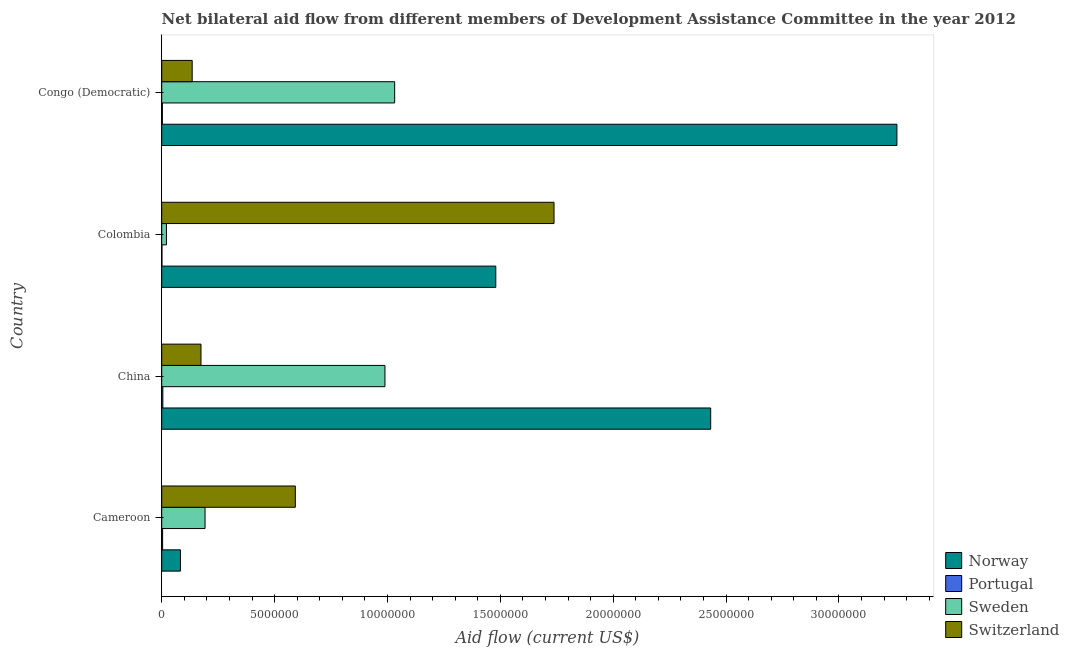How many groups of bars are there?
Provide a succinct answer. 4. Are the number of bars per tick equal to the number of legend labels?
Your response must be concise. Yes. What is the label of the 1st group of bars from the top?
Offer a very short reply. Congo (Democratic). In how many cases, is the number of bars for a given country not equal to the number of legend labels?
Keep it short and to the point. 0. What is the amount of aid given by switzerland in Colombia?
Offer a terse response. 1.74e+07. Across all countries, what is the maximum amount of aid given by portugal?
Offer a very short reply. 5.00e+04. Across all countries, what is the minimum amount of aid given by norway?
Offer a very short reply. 8.30e+05. In which country was the amount of aid given by sweden maximum?
Your response must be concise. Congo (Democratic). What is the total amount of aid given by switzerland in the graph?
Offer a very short reply. 2.64e+07. What is the difference between the amount of aid given by norway in Cameroon and that in Colombia?
Give a very brief answer. -1.40e+07. What is the difference between the amount of aid given by norway in China and the amount of aid given by switzerland in Colombia?
Provide a succinct answer. 6.94e+06. What is the average amount of aid given by norway per country?
Ensure brevity in your answer.  1.81e+07. What is the difference between the amount of aid given by portugal and amount of aid given by sweden in Colombia?
Your response must be concise. -2.00e+05. Is the amount of aid given by norway in Cameroon less than that in Colombia?
Your answer should be compact. Yes. What is the difference between the highest and the second highest amount of aid given by norway?
Offer a terse response. 8.25e+06. What is the difference between the highest and the lowest amount of aid given by norway?
Provide a succinct answer. 3.17e+07. In how many countries, is the amount of aid given by norway greater than the average amount of aid given by norway taken over all countries?
Your answer should be very brief. 2. What does the 2nd bar from the top in Colombia represents?
Keep it short and to the point. Sweden. Are the values on the major ticks of X-axis written in scientific E-notation?
Your response must be concise. No. Does the graph contain grids?
Your answer should be compact. No. How many legend labels are there?
Keep it short and to the point. 4. How are the legend labels stacked?
Your answer should be compact. Vertical. What is the title of the graph?
Give a very brief answer. Net bilateral aid flow from different members of Development Assistance Committee in the year 2012. What is the label or title of the Y-axis?
Provide a short and direct response. Country. What is the Aid flow (current US$) in Norway in Cameroon?
Provide a succinct answer. 8.30e+05. What is the Aid flow (current US$) in Portugal in Cameroon?
Provide a short and direct response. 4.00e+04. What is the Aid flow (current US$) of Sweden in Cameroon?
Give a very brief answer. 1.92e+06. What is the Aid flow (current US$) of Switzerland in Cameroon?
Ensure brevity in your answer.  5.92e+06. What is the Aid flow (current US$) of Norway in China?
Offer a very short reply. 2.43e+07. What is the Aid flow (current US$) in Portugal in China?
Make the answer very short. 5.00e+04. What is the Aid flow (current US$) of Sweden in China?
Provide a succinct answer. 9.89e+06. What is the Aid flow (current US$) of Switzerland in China?
Provide a succinct answer. 1.74e+06. What is the Aid flow (current US$) of Norway in Colombia?
Your response must be concise. 1.48e+07. What is the Aid flow (current US$) in Sweden in Colombia?
Your response must be concise. 2.10e+05. What is the Aid flow (current US$) in Switzerland in Colombia?
Your answer should be very brief. 1.74e+07. What is the Aid flow (current US$) in Norway in Congo (Democratic)?
Your answer should be compact. 3.26e+07. What is the Aid flow (current US$) of Sweden in Congo (Democratic)?
Provide a short and direct response. 1.03e+07. What is the Aid flow (current US$) in Switzerland in Congo (Democratic)?
Offer a terse response. 1.35e+06. Across all countries, what is the maximum Aid flow (current US$) of Norway?
Provide a succinct answer. 3.26e+07. Across all countries, what is the maximum Aid flow (current US$) of Sweden?
Offer a very short reply. 1.03e+07. Across all countries, what is the maximum Aid flow (current US$) in Switzerland?
Keep it short and to the point. 1.74e+07. Across all countries, what is the minimum Aid flow (current US$) in Norway?
Keep it short and to the point. 8.30e+05. Across all countries, what is the minimum Aid flow (current US$) in Portugal?
Ensure brevity in your answer.  10000. Across all countries, what is the minimum Aid flow (current US$) in Sweden?
Provide a short and direct response. 2.10e+05. Across all countries, what is the minimum Aid flow (current US$) of Switzerland?
Your answer should be very brief. 1.35e+06. What is the total Aid flow (current US$) of Norway in the graph?
Offer a very short reply. 7.25e+07. What is the total Aid flow (current US$) in Sweden in the graph?
Provide a succinct answer. 2.23e+07. What is the total Aid flow (current US$) in Switzerland in the graph?
Your response must be concise. 2.64e+07. What is the difference between the Aid flow (current US$) in Norway in Cameroon and that in China?
Provide a succinct answer. -2.35e+07. What is the difference between the Aid flow (current US$) in Portugal in Cameroon and that in China?
Your response must be concise. -10000. What is the difference between the Aid flow (current US$) of Sweden in Cameroon and that in China?
Offer a terse response. -7.97e+06. What is the difference between the Aid flow (current US$) in Switzerland in Cameroon and that in China?
Offer a terse response. 4.18e+06. What is the difference between the Aid flow (current US$) of Norway in Cameroon and that in Colombia?
Your response must be concise. -1.40e+07. What is the difference between the Aid flow (current US$) of Portugal in Cameroon and that in Colombia?
Ensure brevity in your answer.  3.00e+04. What is the difference between the Aid flow (current US$) in Sweden in Cameroon and that in Colombia?
Offer a terse response. 1.71e+06. What is the difference between the Aid flow (current US$) in Switzerland in Cameroon and that in Colombia?
Give a very brief answer. -1.15e+07. What is the difference between the Aid flow (current US$) of Norway in Cameroon and that in Congo (Democratic)?
Ensure brevity in your answer.  -3.17e+07. What is the difference between the Aid flow (current US$) of Portugal in Cameroon and that in Congo (Democratic)?
Your answer should be compact. 10000. What is the difference between the Aid flow (current US$) in Sweden in Cameroon and that in Congo (Democratic)?
Offer a terse response. -8.40e+06. What is the difference between the Aid flow (current US$) of Switzerland in Cameroon and that in Congo (Democratic)?
Give a very brief answer. 4.57e+06. What is the difference between the Aid flow (current US$) in Norway in China and that in Colombia?
Make the answer very short. 9.52e+06. What is the difference between the Aid flow (current US$) in Portugal in China and that in Colombia?
Keep it short and to the point. 4.00e+04. What is the difference between the Aid flow (current US$) in Sweden in China and that in Colombia?
Provide a succinct answer. 9.68e+06. What is the difference between the Aid flow (current US$) in Switzerland in China and that in Colombia?
Your answer should be very brief. -1.56e+07. What is the difference between the Aid flow (current US$) of Norway in China and that in Congo (Democratic)?
Your answer should be compact. -8.25e+06. What is the difference between the Aid flow (current US$) in Sweden in China and that in Congo (Democratic)?
Provide a short and direct response. -4.30e+05. What is the difference between the Aid flow (current US$) in Norway in Colombia and that in Congo (Democratic)?
Provide a short and direct response. -1.78e+07. What is the difference between the Aid flow (current US$) of Sweden in Colombia and that in Congo (Democratic)?
Offer a very short reply. -1.01e+07. What is the difference between the Aid flow (current US$) of Switzerland in Colombia and that in Congo (Democratic)?
Give a very brief answer. 1.60e+07. What is the difference between the Aid flow (current US$) of Norway in Cameroon and the Aid flow (current US$) of Portugal in China?
Offer a terse response. 7.80e+05. What is the difference between the Aid flow (current US$) in Norway in Cameroon and the Aid flow (current US$) in Sweden in China?
Your response must be concise. -9.06e+06. What is the difference between the Aid flow (current US$) of Norway in Cameroon and the Aid flow (current US$) of Switzerland in China?
Provide a short and direct response. -9.10e+05. What is the difference between the Aid flow (current US$) in Portugal in Cameroon and the Aid flow (current US$) in Sweden in China?
Offer a very short reply. -9.85e+06. What is the difference between the Aid flow (current US$) in Portugal in Cameroon and the Aid flow (current US$) in Switzerland in China?
Your answer should be very brief. -1.70e+06. What is the difference between the Aid flow (current US$) of Norway in Cameroon and the Aid flow (current US$) of Portugal in Colombia?
Ensure brevity in your answer.  8.20e+05. What is the difference between the Aid flow (current US$) in Norway in Cameroon and the Aid flow (current US$) in Sweden in Colombia?
Provide a short and direct response. 6.20e+05. What is the difference between the Aid flow (current US$) in Norway in Cameroon and the Aid flow (current US$) in Switzerland in Colombia?
Offer a terse response. -1.66e+07. What is the difference between the Aid flow (current US$) of Portugal in Cameroon and the Aid flow (current US$) of Switzerland in Colombia?
Provide a short and direct response. -1.73e+07. What is the difference between the Aid flow (current US$) of Sweden in Cameroon and the Aid flow (current US$) of Switzerland in Colombia?
Your answer should be very brief. -1.55e+07. What is the difference between the Aid flow (current US$) in Norway in Cameroon and the Aid flow (current US$) in Sweden in Congo (Democratic)?
Offer a terse response. -9.49e+06. What is the difference between the Aid flow (current US$) in Norway in Cameroon and the Aid flow (current US$) in Switzerland in Congo (Democratic)?
Ensure brevity in your answer.  -5.20e+05. What is the difference between the Aid flow (current US$) of Portugal in Cameroon and the Aid flow (current US$) of Sweden in Congo (Democratic)?
Offer a terse response. -1.03e+07. What is the difference between the Aid flow (current US$) of Portugal in Cameroon and the Aid flow (current US$) of Switzerland in Congo (Democratic)?
Provide a succinct answer. -1.31e+06. What is the difference between the Aid flow (current US$) in Sweden in Cameroon and the Aid flow (current US$) in Switzerland in Congo (Democratic)?
Offer a very short reply. 5.70e+05. What is the difference between the Aid flow (current US$) in Norway in China and the Aid flow (current US$) in Portugal in Colombia?
Your answer should be very brief. 2.43e+07. What is the difference between the Aid flow (current US$) of Norway in China and the Aid flow (current US$) of Sweden in Colombia?
Make the answer very short. 2.41e+07. What is the difference between the Aid flow (current US$) in Norway in China and the Aid flow (current US$) in Switzerland in Colombia?
Make the answer very short. 6.94e+06. What is the difference between the Aid flow (current US$) in Portugal in China and the Aid flow (current US$) in Sweden in Colombia?
Your response must be concise. -1.60e+05. What is the difference between the Aid flow (current US$) of Portugal in China and the Aid flow (current US$) of Switzerland in Colombia?
Offer a terse response. -1.73e+07. What is the difference between the Aid flow (current US$) of Sweden in China and the Aid flow (current US$) of Switzerland in Colombia?
Offer a terse response. -7.49e+06. What is the difference between the Aid flow (current US$) of Norway in China and the Aid flow (current US$) of Portugal in Congo (Democratic)?
Your answer should be very brief. 2.43e+07. What is the difference between the Aid flow (current US$) in Norway in China and the Aid flow (current US$) in Sweden in Congo (Democratic)?
Ensure brevity in your answer.  1.40e+07. What is the difference between the Aid flow (current US$) in Norway in China and the Aid flow (current US$) in Switzerland in Congo (Democratic)?
Your answer should be very brief. 2.30e+07. What is the difference between the Aid flow (current US$) of Portugal in China and the Aid flow (current US$) of Sweden in Congo (Democratic)?
Your answer should be very brief. -1.03e+07. What is the difference between the Aid flow (current US$) of Portugal in China and the Aid flow (current US$) of Switzerland in Congo (Democratic)?
Your answer should be compact. -1.30e+06. What is the difference between the Aid flow (current US$) in Sweden in China and the Aid flow (current US$) in Switzerland in Congo (Democratic)?
Your answer should be very brief. 8.54e+06. What is the difference between the Aid flow (current US$) of Norway in Colombia and the Aid flow (current US$) of Portugal in Congo (Democratic)?
Your answer should be very brief. 1.48e+07. What is the difference between the Aid flow (current US$) of Norway in Colombia and the Aid flow (current US$) of Sweden in Congo (Democratic)?
Your response must be concise. 4.48e+06. What is the difference between the Aid flow (current US$) in Norway in Colombia and the Aid flow (current US$) in Switzerland in Congo (Democratic)?
Your answer should be very brief. 1.34e+07. What is the difference between the Aid flow (current US$) of Portugal in Colombia and the Aid flow (current US$) of Sweden in Congo (Democratic)?
Give a very brief answer. -1.03e+07. What is the difference between the Aid flow (current US$) of Portugal in Colombia and the Aid flow (current US$) of Switzerland in Congo (Democratic)?
Your response must be concise. -1.34e+06. What is the difference between the Aid flow (current US$) of Sweden in Colombia and the Aid flow (current US$) of Switzerland in Congo (Democratic)?
Make the answer very short. -1.14e+06. What is the average Aid flow (current US$) in Norway per country?
Make the answer very short. 1.81e+07. What is the average Aid flow (current US$) of Portugal per country?
Provide a short and direct response. 3.25e+04. What is the average Aid flow (current US$) in Sweden per country?
Your response must be concise. 5.58e+06. What is the average Aid flow (current US$) in Switzerland per country?
Ensure brevity in your answer.  6.60e+06. What is the difference between the Aid flow (current US$) of Norway and Aid flow (current US$) of Portugal in Cameroon?
Your response must be concise. 7.90e+05. What is the difference between the Aid flow (current US$) of Norway and Aid flow (current US$) of Sweden in Cameroon?
Provide a short and direct response. -1.09e+06. What is the difference between the Aid flow (current US$) in Norway and Aid flow (current US$) in Switzerland in Cameroon?
Provide a short and direct response. -5.09e+06. What is the difference between the Aid flow (current US$) in Portugal and Aid flow (current US$) in Sweden in Cameroon?
Your response must be concise. -1.88e+06. What is the difference between the Aid flow (current US$) of Portugal and Aid flow (current US$) of Switzerland in Cameroon?
Keep it short and to the point. -5.88e+06. What is the difference between the Aid flow (current US$) of Sweden and Aid flow (current US$) of Switzerland in Cameroon?
Your answer should be very brief. -4.00e+06. What is the difference between the Aid flow (current US$) in Norway and Aid flow (current US$) in Portugal in China?
Offer a very short reply. 2.43e+07. What is the difference between the Aid flow (current US$) of Norway and Aid flow (current US$) of Sweden in China?
Ensure brevity in your answer.  1.44e+07. What is the difference between the Aid flow (current US$) of Norway and Aid flow (current US$) of Switzerland in China?
Keep it short and to the point. 2.26e+07. What is the difference between the Aid flow (current US$) of Portugal and Aid flow (current US$) of Sweden in China?
Make the answer very short. -9.84e+06. What is the difference between the Aid flow (current US$) of Portugal and Aid flow (current US$) of Switzerland in China?
Provide a succinct answer. -1.69e+06. What is the difference between the Aid flow (current US$) in Sweden and Aid flow (current US$) in Switzerland in China?
Your answer should be very brief. 8.15e+06. What is the difference between the Aid flow (current US$) in Norway and Aid flow (current US$) in Portugal in Colombia?
Your response must be concise. 1.48e+07. What is the difference between the Aid flow (current US$) in Norway and Aid flow (current US$) in Sweden in Colombia?
Offer a terse response. 1.46e+07. What is the difference between the Aid flow (current US$) of Norway and Aid flow (current US$) of Switzerland in Colombia?
Provide a succinct answer. -2.58e+06. What is the difference between the Aid flow (current US$) in Portugal and Aid flow (current US$) in Sweden in Colombia?
Provide a succinct answer. -2.00e+05. What is the difference between the Aid flow (current US$) in Portugal and Aid flow (current US$) in Switzerland in Colombia?
Offer a terse response. -1.74e+07. What is the difference between the Aid flow (current US$) of Sweden and Aid flow (current US$) of Switzerland in Colombia?
Keep it short and to the point. -1.72e+07. What is the difference between the Aid flow (current US$) in Norway and Aid flow (current US$) in Portugal in Congo (Democratic)?
Give a very brief answer. 3.25e+07. What is the difference between the Aid flow (current US$) of Norway and Aid flow (current US$) of Sweden in Congo (Democratic)?
Make the answer very short. 2.22e+07. What is the difference between the Aid flow (current US$) in Norway and Aid flow (current US$) in Switzerland in Congo (Democratic)?
Offer a terse response. 3.12e+07. What is the difference between the Aid flow (current US$) of Portugal and Aid flow (current US$) of Sweden in Congo (Democratic)?
Provide a succinct answer. -1.03e+07. What is the difference between the Aid flow (current US$) of Portugal and Aid flow (current US$) of Switzerland in Congo (Democratic)?
Your answer should be compact. -1.32e+06. What is the difference between the Aid flow (current US$) of Sweden and Aid flow (current US$) of Switzerland in Congo (Democratic)?
Make the answer very short. 8.97e+06. What is the ratio of the Aid flow (current US$) of Norway in Cameroon to that in China?
Provide a short and direct response. 0.03. What is the ratio of the Aid flow (current US$) of Sweden in Cameroon to that in China?
Your answer should be very brief. 0.19. What is the ratio of the Aid flow (current US$) in Switzerland in Cameroon to that in China?
Your answer should be very brief. 3.4. What is the ratio of the Aid flow (current US$) of Norway in Cameroon to that in Colombia?
Provide a short and direct response. 0.06. What is the ratio of the Aid flow (current US$) of Sweden in Cameroon to that in Colombia?
Provide a succinct answer. 9.14. What is the ratio of the Aid flow (current US$) in Switzerland in Cameroon to that in Colombia?
Your answer should be very brief. 0.34. What is the ratio of the Aid flow (current US$) of Norway in Cameroon to that in Congo (Democratic)?
Offer a very short reply. 0.03. What is the ratio of the Aid flow (current US$) in Sweden in Cameroon to that in Congo (Democratic)?
Offer a very short reply. 0.19. What is the ratio of the Aid flow (current US$) in Switzerland in Cameroon to that in Congo (Democratic)?
Offer a very short reply. 4.39. What is the ratio of the Aid flow (current US$) in Norway in China to that in Colombia?
Your response must be concise. 1.64. What is the ratio of the Aid flow (current US$) of Sweden in China to that in Colombia?
Make the answer very short. 47.1. What is the ratio of the Aid flow (current US$) of Switzerland in China to that in Colombia?
Your response must be concise. 0.1. What is the ratio of the Aid flow (current US$) of Norway in China to that in Congo (Democratic)?
Offer a very short reply. 0.75. What is the ratio of the Aid flow (current US$) of Portugal in China to that in Congo (Democratic)?
Your answer should be compact. 1.67. What is the ratio of the Aid flow (current US$) in Switzerland in China to that in Congo (Democratic)?
Provide a short and direct response. 1.29. What is the ratio of the Aid flow (current US$) in Norway in Colombia to that in Congo (Democratic)?
Your answer should be compact. 0.45. What is the ratio of the Aid flow (current US$) of Portugal in Colombia to that in Congo (Democratic)?
Your response must be concise. 0.33. What is the ratio of the Aid flow (current US$) in Sweden in Colombia to that in Congo (Democratic)?
Provide a short and direct response. 0.02. What is the ratio of the Aid flow (current US$) in Switzerland in Colombia to that in Congo (Democratic)?
Provide a short and direct response. 12.87. What is the difference between the highest and the second highest Aid flow (current US$) of Norway?
Your response must be concise. 8.25e+06. What is the difference between the highest and the second highest Aid flow (current US$) of Portugal?
Offer a very short reply. 10000. What is the difference between the highest and the second highest Aid flow (current US$) of Switzerland?
Make the answer very short. 1.15e+07. What is the difference between the highest and the lowest Aid flow (current US$) in Norway?
Ensure brevity in your answer.  3.17e+07. What is the difference between the highest and the lowest Aid flow (current US$) in Sweden?
Offer a very short reply. 1.01e+07. What is the difference between the highest and the lowest Aid flow (current US$) of Switzerland?
Offer a very short reply. 1.60e+07. 